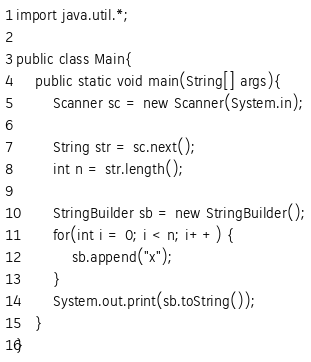<code> <loc_0><loc_0><loc_500><loc_500><_Java_>import java.util.*;

public class Main{
    public static void main(String[] args){
        Scanner sc = new Scanner(System.in);

        String str = sc.next();
        int n = str.length();

        StringBuilder sb = new StringBuilder();
        for(int i = 0; i < n; i++) {
            sb.append("x");
        }
        System.out.print(sb.toString());
    }
}
</code> 